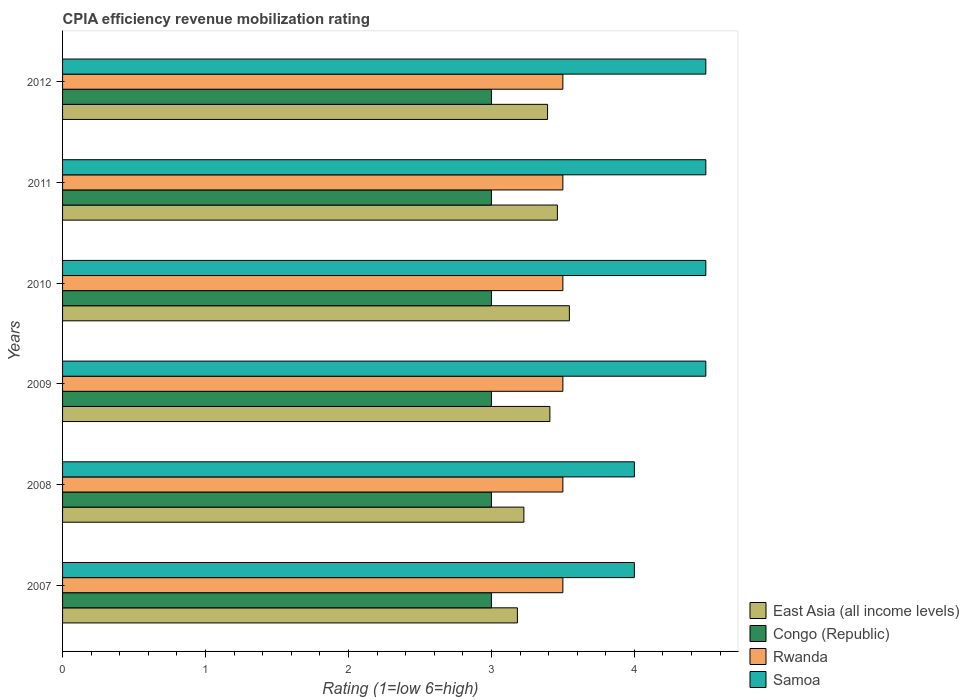How many different coloured bars are there?
Your response must be concise. 4. Are the number of bars on each tick of the Y-axis equal?
Offer a very short reply. Yes. What is the label of the 6th group of bars from the top?
Give a very brief answer. 2007. In how many cases, is the number of bars for a given year not equal to the number of legend labels?
Offer a very short reply. 0. What is the CPIA rating in Samoa in 2009?
Provide a succinct answer. 4.5. Across all years, what is the maximum CPIA rating in East Asia (all income levels)?
Provide a succinct answer. 3.55. Across all years, what is the minimum CPIA rating in Congo (Republic)?
Your answer should be very brief. 3. In which year was the CPIA rating in Rwanda minimum?
Your answer should be very brief. 2007. What is the total CPIA rating in Samoa in the graph?
Your answer should be very brief. 26. What is the difference between the CPIA rating in East Asia (all income levels) in 2008 and that in 2009?
Your response must be concise. -0.18. What is the difference between the CPIA rating in East Asia (all income levels) in 2010 and the CPIA rating in Rwanda in 2007?
Provide a succinct answer. 0.05. What is the average CPIA rating in East Asia (all income levels) per year?
Your answer should be very brief. 3.37. In the year 2012, what is the difference between the CPIA rating in Congo (Republic) and CPIA rating in East Asia (all income levels)?
Offer a terse response. -0.39. What is the ratio of the CPIA rating in Samoa in 2008 to that in 2011?
Provide a short and direct response. 0.89. What is the difference between the highest and the second highest CPIA rating in East Asia (all income levels)?
Give a very brief answer. 0.08. What is the difference between the highest and the lowest CPIA rating in East Asia (all income levels)?
Make the answer very short. 0.36. In how many years, is the CPIA rating in Rwanda greater than the average CPIA rating in Rwanda taken over all years?
Make the answer very short. 0. Is it the case that in every year, the sum of the CPIA rating in Samoa and CPIA rating in Congo (Republic) is greater than the sum of CPIA rating in East Asia (all income levels) and CPIA rating in Rwanda?
Your answer should be very brief. Yes. What does the 3rd bar from the top in 2011 represents?
Provide a succinct answer. Congo (Republic). What does the 2nd bar from the bottom in 2010 represents?
Ensure brevity in your answer.  Congo (Republic). Is it the case that in every year, the sum of the CPIA rating in East Asia (all income levels) and CPIA rating in Samoa is greater than the CPIA rating in Congo (Republic)?
Provide a short and direct response. Yes. How many bars are there?
Offer a terse response. 24. Are all the bars in the graph horizontal?
Offer a terse response. Yes. How many years are there in the graph?
Make the answer very short. 6. What is the difference between two consecutive major ticks on the X-axis?
Your answer should be compact. 1. Does the graph contain any zero values?
Your response must be concise. No. Where does the legend appear in the graph?
Offer a terse response. Bottom right. What is the title of the graph?
Provide a succinct answer. CPIA efficiency revenue mobilization rating. What is the label or title of the X-axis?
Provide a succinct answer. Rating (1=low 6=high). What is the label or title of the Y-axis?
Your answer should be compact. Years. What is the Rating (1=low 6=high) of East Asia (all income levels) in 2007?
Provide a succinct answer. 3.18. What is the Rating (1=low 6=high) of Samoa in 2007?
Offer a very short reply. 4. What is the Rating (1=low 6=high) in East Asia (all income levels) in 2008?
Keep it short and to the point. 3.23. What is the Rating (1=low 6=high) in Congo (Republic) in 2008?
Make the answer very short. 3. What is the Rating (1=low 6=high) in East Asia (all income levels) in 2009?
Offer a terse response. 3.41. What is the Rating (1=low 6=high) in East Asia (all income levels) in 2010?
Provide a short and direct response. 3.55. What is the Rating (1=low 6=high) of Congo (Republic) in 2010?
Give a very brief answer. 3. What is the Rating (1=low 6=high) of Rwanda in 2010?
Your answer should be very brief. 3.5. What is the Rating (1=low 6=high) of East Asia (all income levels) in 2011?
Your answer should be compact. 3.46. What is the Rating (1=low 6=high) of Congo (Republic) in 2011?
Your response must be concise. 3. What is the Rating (1=low 6=high) of Rwanda in 2011?
Give a very brief answer. 3.5. What is the Rating (1=low 6=high) in East Asia (all income levels) in 2012?
Ensure brevity in your answer.  3.39. What is the Rating (1=low 6=high) in Samoa in 2012?
Make the answer very short. 4.5. Across all years, what is the maximum Rating (1=low 6=high) in East Asia (all income levels)?
Provide a short and direct response. 3.55. Across all years, what is the maximum Rating (1=low 6=high) in Congo (Republic)?
Your response must be concise. 3. Across all years, what is the minimum Rating (1=low 6=high) of East Asia (all income levels)?
Ensure brevity in your answer.  3.18. Across all years, what is the minimum Rating (1=low 6=high) of Rwanda?
Keep it short and to the point. 3.5. Across all years, what is the minimum Rating (1=low 6=high) of Samoa?
Offer a terse response. 4. What is the total Rating (1=low 6=high) of East Asia (all income levels) in the graph?
Provide a short and direct response. 20.22. What is the total Rating (1=low 6=high) in Congo (Republic) in the graph?
Make the answer very short. 18. What is the total Rating (1=low 6=high) in Rwanda in the graph?
Your response must be concise. 21. What is the total Rating (1=low 6=high) in Samoa in the graph?
Make the answer very short. 26. What is the difference between the Rating (1=low 6=high) of East Asia (all income levels) in 2007 and that in 2008?
Provide a short and direct response. -0.05. What is the difference between the Rating (1=low 6=high) in Congo (Republic) in 2007 and that in 2008?
Make the answer very short. 0. What is the difference between the Rating (1=low 6=high) in Rwanda in 2007 and that in 2008?
Provide a succinct answer. 0. What is the difference between the Rating (1=low 6=high) of Samoa in 2007 and that in 2008?
Give a very brief answer. 0. What is the difference between the Rating (1=low 6=high) of East Asia (all income levels) in 2007 and that in 2009?
Keep it short and to the point. -0.23. What is the difference between the Rating (1=low 6=high) of East Asia (all income levels) in 2007 and that in 2010?
Give a very brief answer. -0.36. What is the difference between the Rating (1=low 6=high) of Congo (Republic) in 2007 and that in 2010?
Your answer should be compact. 0. What is the difference between the Rating (1=low 6=high) of Rwanda in 2007 and that in 2010?
Provide a short and direct response. 0. What is the difference between the Rating (1=low 6=high) in East Asia (all income levels) in 2007 and that in 2011?
Your answer should be very brief. -0.28. What is the difference between the Rating (1=low 6=high) in Congo (Republic) in 2007 and that in 2011?
Offer a very short reply. 0. What is the difference between the Rating (1=low 6=high) in Rwanda in 2007 and that in 2011?
Offer a very short reply. 0. What is the difference between the Rating (1=low 6=high) in Samoa in 2007 and that in 2011?
Your response must be concise. -0.5. What is the difference between the Rating (1=low 6=high) in East Asia (all income levels) in 2007 and that in 2012?
Provide a succinct answer. -0.21. What is the difference between the Rating (1=low 6=high) in Samoa in 2007 and that in 2012?
Provide a short and direct response. -0.5. What is the difference between the Rating (1=low 6=high) in East Asia (all income levels) in 2008 and that in 2009?
Keep it short and to the point. -0.18. What is the difference between the Rating (1=low 6=high) in Congo (Republic) in 2008 and that in 2009?
Ensure brevity in your answer.  0. What is the difference between the Rating (1=low 6=high) in Samoa in 2008 and that in 2009?
Offer a very short reply. -0.5. What is the difference between the Rating (1=low 6=high) in East Asia (all income levels) in 2008 and that in 2010?
Offer a very short reply. -0.32. What is the difference between the Rating (1=low 6=high) in East Asia (all income levels) in 2008 and that in 2011?
Provide a succinct answer. -0.23. What is the difference between the Rating (1=low 6=high) in Rwanda in 2008 and that in 2011?
Your answer should be compact. 0. What is the difference between the Rating (1=low 6=high) in East Asia (all income levels) in 2008 and that in 2012?
Offer a very short reply. -0.17. What is the difference between the Rating (1=low 6=high) of Congo (Republic) in 2008 and that in 2012?
Offer a very short reply. 0. What is the difference between the Rating (1=low 6=high) in East Asia (all income levels) in 2009 and that in 2010?
Your answer should be very brief. -0.14. What is the difference between the Rating (1=low 6=high) of Congo (Republic) in 2009 and that in 2010?
Provide a succinct answer. 0. What is the difference between the Rating (1=low 6=high) of Rwanda in 2009 and that in 2010?
Provide a short and direct response. 0. What is the difference between the Rating (1=low 6=high) of Samoa in 2009 and that in 2010?
Provide a succinct answer. 0. What is the difference between the Rating (1=low 6=high) in East Asia (all income levels) in 2009 and that in 2011?
Ensure brevity in your answer.  -0.05. What is the difference between the Rating (1=low 6=high) of Rwanda in 2009 and that in 2011?
Your answer should be compact. 0. What is the difference between the Rating (1=low 6=high) of East Asia (all income levels) in 2009 and that in 2012?
Your answer should be very brief. 0.02. What is the difference between the Rating (1=low 6=high) of Congo (Republic) in 2009 and that in 2012?
Your answer should be very brief. 0. What is the difference between the Rating (1=low 6=high) of East Asia (all income levels) in 2010 and that in 2011?
Give a very brief answer. 0.08. What is the difference between the Rating (1=low 6=high) in Congo (Republic) in 2010 and that in 2011?
Your response must be concise. 0. What is the difference between the Rating (1=low 6=high) in Rwanda in 2010 and that in 2011?
Give a very brief answer. 0. What is the difference between the Rating (1=low 6=high) of East Asia (all income levels) in 2010 and that in 2012?
Your answer should be very brief. 0.15. What is the difference between the Rating (1=low 6=high) in Congo (Republic) in 2010 and that in 2012?
Give a very brief answer. 0. What is the difference between the Rating (1=low 6=high) of Samoa in 2010 and that in 2012?
Give a very brief answer. 0. What is the difference between the Rating (1=low 6=high) in East Asia (all income levels) in 2011 and that in 2012?
Ensure brevity in your answer.  0.07. What is the difference between the Rating (1=low 6=high) in Congo (Republic) in 2011 and that in 2012?
Your answer should be compact. 0. What is the difference between the Rating (1=low 6=high) in Rwanda in 2011 and that in 2012?
Offer a terse response. 0. What is the difference between the Rating (1=low 6=high) of Samoa in 2011 and that in 2012?
Your response must be concise. 0. What is the difference between the Rating (1=low 6=high) of East Asia (all income levels) in 2007 and the Rating (1=low 6=high) of Congo (Republic) in 2008?
Provide a succinct answer. 0.18. What is the difference between the Rating (1=low 6=high) of East Asia (all income levels) in 2007 and the Rating (1=low 6=high) of Rwanda in 2008?
Make the answer very short. -0.32. What is the difference between the Rating (1=low 6=high) in East Asia (all income levels) in 2007 and the Rating (1=low 6=high) in Samoa in 2008?
Give a very brief answer. -0.82. What is the difference between the Rating (1=low 6=high) in Rwanda in 2007 and the Rating (1=low 6=high) in Samoa in 2008?
Provide a succinct answer. -0.5. What is the difference between the Rating (1=low 6=high) of East Asia (all income levels) in 2007 and the Rating (1=low 6=high) of Congo (Republic) in 2009?
Keep it short and to the point. 0.18. What is the difference between the Rating (1=low 6=high) of East Asia (all income levels) in 2007 and the Rating (1=low 6=high) of Rwanda in 2009?
Keep it short and to the point. -0.32. What is the difference between the Rating (1=low 6=high) in East Asia (all income levels) in 2007 and the Rating (1=low 6=high) in Samoa in 2009?
Provide a short and direct response. -1.32. What is the difference between the Rating (1=low 6=high) in East Asia (all income levels) in 2007 and the Rating (1=low 6=high) in Congo (Republic) in 2010?
Provide a succinct answer. 0.18. What is the difference between the Rating (1=low 6=high) of East Asia (all income levels) in 2007 and the Rating (1=low 6=high) of Rwanda in 2010?
Offer a terse response. -0.32. What is the difference between the Rating (1=low 6=high) in East Asia (all income levels) in 2007 and the Rating (1=low 6=high) in Samoa in 2010?
Provide a short and direct response. -1.32. What is the difference between the Rating (1=low 6=high) of Congo (Republic) in 2007 and the Rating (1=low 6=high) of Rwanda in 2010?
Give a very brief answer. -0.5. What is the difference between the Rating (1=low 6=high) in Congo (Republic) in 2007 and the Rating (1=low 6=high) in Samoa in 2010?
Your response must be concise. -1.5. What is the difference between the Rating (1=low 6=high) in East Asia (all income levels) in 2007 and the Rating (1=low 6=high) in Congo (Republic) in 2011?
Ensure brevity in your answer.  0.18. What is the difference between the Rating (1=low 6=high) of East Asia (all income levels) in 2007 and the Rating (1=low 6=high) of Rwanda in 2011?
Your response must be concise. -0.32. What is the difference between the Rating (1=low 6=high) of East Asia (all income levels) in 2007 and the Rating (1=low 6=high) of Samoa in 2011?
Your answer should be very brief. -1.32. What is the difference between the Rating (1=low 6=high) of Congo (Republic) in 2007 and the Rating (1=low 6=high) of Rwanda in 2011?
Your answer should be compact. -0.5. What is the difference between the Rating (1=low 6=high) in Rwanda in 2007 and the Rating (1=low 6=high) in Samoa in 2011?
Offer a very short reply. -1. What is the difference between the Rating (1=low 6=high) of East Asia (all income levels) in 2007 and the Rating (1=low 6=high) of Congo (Republic) in 2012?
Your answer should be compact. 0.18. What is the difference between the Rating (1=low 6=high) of East Asia (all income levels) in 2007 and the Rating (1=low 6=high) of Rwanda in 2012?
Give a very brief answer. -0.32. What is the difference between the Rating (1=low 6=high) in East Asia (all income levels) in 2007 and the Rating (1=low 6=high) in Samoa in 2012?
Your answer should be compact. -1.32. What is the difference between the Rating (1=low 6=high) of Congo (Republic) in 2007 and the Rating (1=low 6=high) of Samoa in 2012?
Provide a succinct answer. -1.5. What is the difference between the Rating (1=low 6=high) of East Asia (all income levels) in 2008 and the Rating (1=low 6=high) of Congo (Republic) in 2009?
Make the answer very short. 0.23. What is the difference between the Rating (1=low 6=high) of East Asia (all income levels) in 2008 and the Rating (1=low 6=high) of Rwanda in 2009?
Your answer should be very brief. -0.27. What is the difference between the Rating (1=low 6=high) in East Asia (all income levels) in 2008 and the Rating (1=low 6=high) in Samoa in 2009?
Ensure brevity in your answer.  -1.27. What is the difference between the Rating (1=low 6=high) in Congo (Republic) in 2008 and the Rating (1=low 6=high) in Rwanda in 2009?
Provide a succinct answer. -0.5. What is the difference between the Rating (1=low 6=high) in Congo (Republic) in 2008 and the Rating (1=low 6=high) in Samoa in 2009?
Your response must be concise. -1.5. What is the difference between the Rating (1=low 6=high) of East Asia (all income levels) in 2008 and the Rating (1=low 6=high) of Congo (Republic) in 2010?
Your answer should be compact. 0.23. What is the difference between the Rating (1=low 6=high) in East Asia (all income levels) in 2008 and the Rating (1=low 6=high) in Rwanda in 2010?
Your response must be concise. -0.27. What is the difference between the Rating (1=low 6=high) of East Asia (all income levels) in 2008 and the Rating (1=low 6=high) of Samoa in 2010?
Your answer should be very brief. -1.27. What is the difference between the Rating (1=low 6=high) of Congo (Republic) in 2008 and the Rating (1=low 6=high) of Rwanda in 2010?
Your response must be concise. -0.5. What is the difference between the Rating (1=low 6=high) of Congo (Republic) in 2008 and the Rating (1=low 6=high) of Samoa in 2010?
Offer a very short reply. -1.5. What is the difference between the Rating (1=low 6=high) in Rwanda in 2008 and the Rating (1=low 6=high) in Samoa in 2010?
Your answer should be compact. -1. What is the difference between the Rating (1=low 6=high) of East Asia (all income levels) in 2008 and the Rating (1=low 6=high) of Congo (Republic) in 2011?
Ensure brevity in your answer.  0.23. What is the difference between the Rating (1=low 6=high) of East Asia (all income levels) in 2008 and the Rating (1=low 6=high) of Rwanda in 2011?
Your answer should be compact. -0.27. What is the difference between the Rating (1=low 6=high) of East Asia (all income levels) in 2008 and the Rating (1=low 6=high) of Samoa in 2011?
Keep it short and to the point. -1.27. What is the difference between the Rating (1=low 6=high) in Congo (Republic) in 2008 and the Rating (1=low 6=high) in Rwanda in 2011?
Make the answer very short. -0.5. What is the difference between the Rating (1=low 6=high) of Congo (Republic) in 2008 and the Rating (1=low 6=high) of Samoa in 2011?
Your answer should be compact. -1.5. What is the difference between the Rating (1=low 6=high) of East Asia (all income levels) in 2008 and the Rating (1=low 6=high) of Congo (Republic) in 2012?
Provide a succinct answer. 0.23. What is the difference between the Rating (1=low 6=high) in East Asia (all income levels) in 2008 and the Rating (1=low 6=high) in Rwanda in 2012?
Provide a short and direct response. -0.27. What is the difference between the Rating (1=low 6=high) in East Asia (all income levels) in 2008 and the Rating (1=low 6=high) in Samoa in 2012?
Make the answer very short. -1.27. What is the difference between the Rating (1=low 6=high) of Congo (Republic) in 2008 and the Rating (1=low 6=high) of Samoa in 2012?
Give a very brief answer. -1.5. What is the difference between the Rating (1=low 6=high) in Rwanda in 2008 and the Rating (1=low 6=high) in Samoa in 2012?
Provide a short and direct response. -1. What is the difference between the Rating (1=low 6=high) in East Asia (all income levels) in 2009 and the Rating (1=low 6=high) in Congo (Republic) in 2010?
Provide a short and direct response. 0.41. What is the difference between the Rating (1=low 6=high) in East Asia (all income levels) in 2009 and the Rating (1=low 6=high) in Rwanda in 2010?
Your response must be concise. -0.09. What is the difference between the Rating (1=low 6=high) of East Asia (all income levels) in 2009 and the Rating (1=low 6=high) of Samoa in 2010?
Provide a short and direct response. -1.09. What is the difference between the Rating (1=low 6=high) in Congo (Republic) in 2009 and the Rating (1=low 6=high) in Rwanda in 2010?
Offer a very short reply. -0.5. What is the difference between the Rating (1=low 6=high) in Rwanda in 2009 and the Rating (1=low 6=high) in Samoa in 2010?
Ensure brevity in your answer.  -1. What is the difference between the Rating (1=low 6=high) in East Asia (all income levels) in 2009 and the Rating (1=low 6=high) in Congo (Republic) in 2011?
Keep it short and to the point. 0.41. What is the difference between the Rating (1=low 6=high) of East Asia (all income levels) in 2009 and the Rating (1=low 6=high) of Rwanda in 2011?
Your answer should be very brief. -0.09. What is the difference between the Rating (1=low 6=high) of East Asia (all income levels) in 2009 and the Rating (1=low 6=high) of Samoa in 2011?
Offer a terse response. -1.09. What is the difference between the Rating (1=low 6=high) in East Asia (all income levels) in 2009 and the Rating (1=low 6=high) in Congo (Republic) in 2012?
Provide a short and direct response. 0.41. What is the difference between the Rating (1=low 6=high) in East Asia (all income levels) in 2009 and the Rating (1=low 6=high) in Rwanda in 2012?
Make the answer very short. -0.09. What is the difference between the Rating (1=low 6=high) of East Asia (all income levels) in 2009 and the Rating (1=low 6=high) of Samoa in 2012?
Your answer should be very brief. -1.09. What is the difference between the Rating (1=low 6=high) of Congo (Republic) in 2009 and the Rating (1=low 6=high) of Rwanda in 2012?
Offer a very short reply. -0.5. What is the difference between the Rating (1=low 6=high) of Congo (Republic) in 2009 and the Rating (1=low 6=high) of Samoa in 2012?
Ensure brevity in your answer.  -1.5. What is the difference between the Rating (1=low 6=high) in East Asia (all income levels) in 2010 and the Rating (1=low 6=high) in Congo (Republic) in 2011?
Make the answer very short. 0.55. What is the difference between the Rating (1=low 6=high) in East Asia (all income levels) in 2010 and the Rating (1=low 6=high) in Rwanda in 2011?
Your response must be concise. 0.05. What is the difference between the Rating (1=low 6=high) of East Asia (all income levels) in 2010 and the Rating (1=low 6=high) of Samoa in 2011?
Keep it short and to the point. -0.95. What is the difference between the Rating (1=low 6=high) of Congo (Republic) in 2010 and the Rating (1=low 6=high) of Rwanda in 2011?
Your answer should be compact. -0.5. What is the difference between the Rating (1=low 6=high) in Rwanda in 2010 and the Rating (1=low 6=high) in Samoa in 2011?
Give a very brief answer. -1. What is the difference between the Rating (1=low 6=high) in East Asia (all income levels) in 2010 and the Rating (1=low 6=high) in Congo (Republic) in 2012?
Provide a short and direct response. 0.55. What is the difference between the Rating (1=low 6=high) in East Asia (all income levels) in 2010 and the Rating (1=low 6=high) in Rwanda in 2012?
Provide a short and direct response. 0.05. What is the difference between the Rating (1=low 6=high) in East Asia (all income levels) in 2010 and the Rating (1=low 6=high) in Samoa in 2012?
Provide a short and direct response. -0.95. What is the difference between the Rating (1=low 6=high) of Rwanda in 2010 and the Rating (1=low 6=high) of Samoa in 2012?
Give a very brief answer. -1. What is the difference between the Rating (1=low 6=high) in East Asia (all income levels) in 2011 and the Rating (1=low 6=high) in Congo (Republic) in 2012?
Keep it short and to the point. 0.46. What is the difference between the Rating (1=low 6=high) in East Asia (all income levels) in 2011 and the Rating (1=low 6=high) in Rwanda in 2012?
Make the answer very short. -0.04. What is the difference between the Rating (1=low 6=high) of East Asia (all income levels) in 2011 and the Rating (1=low 6=high) of Samoa in 2012?
Your response must be concise. -1.04. What is the difference between the Rating (1=low 6=high) in Congo (Republic) in 2011 and the Rating (1=low 6=high) in Rwanda in 2012?
Ensure brevity in your answer.  -0.5. What is the average Rating (1=low 6=high) of East Asia (all income levels) per year?
Offer a very short reply. 3.37. What is the average Rating (1=low 6=high) in Congo (Republic) per year?
Your response must be concise. 3. What is the average Rating (1=low 6=high) in Samoa per year?
Your answer should be very brief. 4.33. In the year 2007, what is the difference between the Rating (1=low 6=high) of East Asia (all income levels) and Rating (1=low 6=high) of Congo (Republic)?
Provide a succinct answer. 0.18. In the year 2007, what is the difference between the Rating (1=low 6=high) of East Asia (all income levels) and Rating (1=low 6=high) of Rwanda?
Your response must be concise. -0.32. In the year 2007, what is the difference between the Rating (1=low 6=high) in East Asia (all income levels) and Rating (1=low 6=high) in Samoa?
Give a very brief answer. -0.82. In the year 2007, what is the difference between the Rating (1=low 6=high) of Congo (Republic) and Rating (1=low 6=high) of Rwanda?
Give a very brief answer. -0.5. In the year 2007, what is the difference between the Rating (1=low 6=high) in Congo (Republic) and Rating (1=low 6=high) in Samoa?
Provide a short and direct response. -1. In the year 2007, what is the difference between the Rating (1=low 6=high) of Rwanda and Rating (1=low 6=high) of Samoa?
Give a very brief answer. -0.5. In the year 2008, what is the difference between the Rating (1=low 6=high) in East Asia (all income levels) and Rating (1=low 6=high) in Congo (Republic)?
Your answer should be very brief. 0.23. In the year 2008, what is the difference between the Rating (1=low 6=high) in East Asia (all income levels) and Rating (1=low 6=high) in Rwanda?
Your response must be concise. -0.27. In the year 2008, what is the difference between the Rating (1=low 6=high) in East Asia (all income levels) and Rating (1=low 6=high) in Samoa?
Make the answer very short. -0.77. In the year 2009, what is the difference between the Rating (1=low 6=high) in East Asia (all income levels) and Rating (1=low 6=high) in Congo (Republic)?
Make the answer very short. 0.41. In the year 2009, what is the difference between the Rating (1=low 6=high) of East Asia (all income levels) and Rating (1=low 6=high) of Rwanda?
Your response must be concise. -0.09. In the year 2009, what is the difference between the Rating (1=low 6=high) in East Asia (all income levels) and Rating (1=low 6=high) in Samoa?
Provide a succinct answer. -1.09. In the year 2010, what is the difference between the Rating (1=low 6=high) of East Asia (all income levels) and Rating (1=low 6=high) of Congo (Republic)?
Give a very brief answer. 0.55. In the year 2010, what is the difference between the Rating (1=low 6=high) in East Asia (all income levels) and Rating (1=low 6=high) in Rwanda?
Give a very brief answer. 0.05. In the year 2010, what is the difference between the Rating (1=low 6=high) in East Asia (all income levels) and Rating (1=low 6=high) in Samoa?
Make the answer very short. -0.95. In the year 2011, what is the difference between the Rating (1=low 6=high) in East Asia (all income levels) and Rating (1=low 6=high) in Congo (Republic)?
Your response must be concise. 0.46. In the year 2011, what is the difference between the Rating (1=low 6=high) of East Asia (all income levels) and Rating (1=low 6=high) of Rwanda?
Your response must be concise. -0.04. In the year 2011, what is the difference between the Rating (1=low 6=high) of East Asia (all income levels) and Rating (1=low 6=high) of Samoa?
Provide a short and direct response. -1.04. In the year 2011, what is the difference between the Rating (1=low 6=high) in Congo (Republic) and Rating (1=low 6=high) in Samoa?
Give a very brief answer. -1.5. In the year 2012, what is the difference between the Rating (1=low 6=high) of East Asia (all income levels) and Rating (1=low 6=high) of Congo (Republic)?
Make the answer very short. 0.39. In the year 2012, what is the difference between the Rating (1=low 6=high) of East Asia (all income levels) and Rating (1=low 6=high) of Rwanda?
Ensure brevity in your answer.  -0.11. In the year 2012, what is the difference between the Rating (1=low 6=high) in East Asia (all income levels) and Rating (1=low 6=high) in Samoa?
Provide a succinct answer. -1.11. In the year 2012, what is the difference between the Rating (1=low 6=high) in Congo (Republic) and Rating (1=low 6=high) in Rwanda?
Your answer should be compact. -0.5. What is the ratio of the Rating (1=low 6=high) of East Asia (all income levels) in 2007 to that in 2008?
Provide a succinct answer. 0.99. What is the ratio of the Rating (1=low 6=high) in East Asia (all income levels) in 2007 to that in 2009?
Your answer should be very brief. 0.93. What is the ratio of the Rating (1=low 6=high) of Congo (Republic) in 2007 to that in 2009?
Keep it short and to the point. 1. What is the ratio of the Rating (1=low 6=high) in Rwanda in 2007 to that in 2009?
Provide a short and direct response. 1. What is the ratio of the Rating (1=low 6=high) of Samoa in 2007 to that in 2009?
Provide a short and direct response. 0.89. What is the ratio of the Rating (1=low 6=high) of East Asia (all income levels) in 2007 to that in 2010?
Your answer should be compact. 0.9. What is the ratio of the Rating (1=low 6=high) of Congo (Republic) in 2007 to that in 2010?
Your response must be concise. 1. What is the ratio of the Rating (1=low 6=high) of Rwanda in 2007 to that in 2010?
Offer a very short reply. 1. What is the ratio of the Rating (1=low 6=high) of East Asia (all income levels) in 2007 to that in 2011?
Your answer should be very brief. 0.92. What is the ratio of the Rating (1=low 6=high) in Rwanda in 2007 to that in 2011?
Keep it short and to the point. 1. What is the ratio of the Rating (1=low 6=high) in Samoa in 2007 to that in 2011?
Provide a short and direct response. 0.89. What is the ratio of the Rating (1=low 6=high) in East Asia (all income levels) in 2007 to that in 2012?
Your response must be concise. 0.94. What is the ratio of the Rating (1=low 6=high) of Congo (Republic) in 2007 to that in 2012?
Your response must be concise. 1. What is the ratio of the Rating (1=low 6=high) in Rwanda in 2007 to that in 2012?
Your answer should be compact. 1. What is the ratio of the Rating (1=low 6=high) in East Asia (all income levels) in 2008 to that in 2009?
Offer a terse response. 0.95. What is the ratio of the Rating (1=low 6=high) of East Asia (all income levels) in 2008 to that in 2010?
Your answer should be very brief. 0.91. What is the ratio of the Rating (1=low 6=high) in Congo (Republic) in 2008 to that in 2010?
Your response must be concise. 1. What is the ratio of the Rating (1=low 6=high) in Rwanda in 2008 to that in 2010?
Offer a very short reply. 1. What is the ratio of the Rating (1=low 6=high) of East Asia (all income levels) in 2008 to that in 2011?
Ensure brevity in your answer.  0.93. What is the ratio of the Rating (1=low 6=high) of Congo (Republic) in 2008 to that in 2011?
Offer a terse response. 1. What is the ratio of the Rating (1=low 6=high) in East Asia (all income levels) in 2008 to that in 2012?
Offer a terse response. 0.95. What is the ratio of the Rating (1=low 6=high) of Congo (Republic) in 2008 to that in 2012?
Your answer should be compact. 1. What is the ratio of the Rating (1=low 6=high) in Samoa in 2008 to that in 2012?
Ensure brevity in your answer.  0.89. What is the ratio of the Rating (1=low 6=high) of East Asia (all income levels) in 2009 to that in 2010?
Your answer should be very brief. 0.96. What is the ratio of the Rating (1=low 6=high) of Congo (Republic) in 2009 to that in 2010?
Offer a very short reply. 1. What is the ratio of the Rating (1=low 6=high) in Samoa in 2009 to that in 2010?
Offer a terse response. 1. What is the ratio of the Rating (1=low 6=high) in East Asia (all income levels) in 2009 to that in 2011?
Your answer should be compact. 0.98. What is the ratio of the Rating (1=low 6=high) of Rwanda in 2009 to that in 2011?
Your answer should be compact. 1. What is the ratio of the Rating (1=low 6=high) in East Asia (all income levels) in 2009 to that in 2012?
Keep it short and to the point. 1. What is the ratio of the Rating (1=low 6=high) in Samoa in 2009 to that in 2012?
Provide a short and direct response. 1. What is the ratio of the Rating (1=low 6=high) in East Asia (all income levels) in 2010 to that in 2011?
Ensure brevity in your answer.  1.02. What is the ratio of the Rating (1=low 6=high) in Congo (Republic) in 2010 to that in 2011?
Give a very brief answer. 1. What is the ratio of the Rating (1=low 6=high) of Rwanda in 2010 to that in 2011?
Provide a short and direct response. 1. What is the ratio of the Rating (1=low 6=high) in Samoa in 2010 to that in 2011?
Ensure brevity in your answer.  1. What is the ratio of the Rating (1=low 6=high) in East Asia (all income levels) in 2010 to that in 2012?
Offer a terse response. 1.04. What is the ratio of the Rating (1=low 6=high) of Congo (Republic) in 2010 to that in 2012?
Give a very brief answer. 1. What is the ratio of the Rating (1=low 6=high) of Rwanda in 2010 to that in 2012?
Your answer should be compact. 1. What is the ratio of the Rating (1=low 6=high) in Samoa in 2010 to that in 2012?
Your answer should be compact. 1. What is the ratio of the Rating (1=low 6=high) of East Asia (all income levels) in 2011 to that in 2012?
Offer a terse response. 1.02. What is the ratio of the Rating (1=low 6=high) in Congo (Republic) in 2011 to that in 2012?
Offer a very short reply. 1. What is the ratio of the Rating (1=low 6=high) in Rwanda in 2011 to that in 2012?
Ensure brevity in your answer.  1. What is the difference between the highest and the second highest Rating (1=low 6=high) in East Asia (all income levels)?
Make the answer very short. 0.08. What is the difference between the highest and the second highest Rating (1=low 6=high) of Rwanda?
Provide a short and direct response. 0. What is the difference between the highest and the lowest Rating (1=low 6=high) of East Asia (all income levels)?
Your response must be concise. 0.36. 